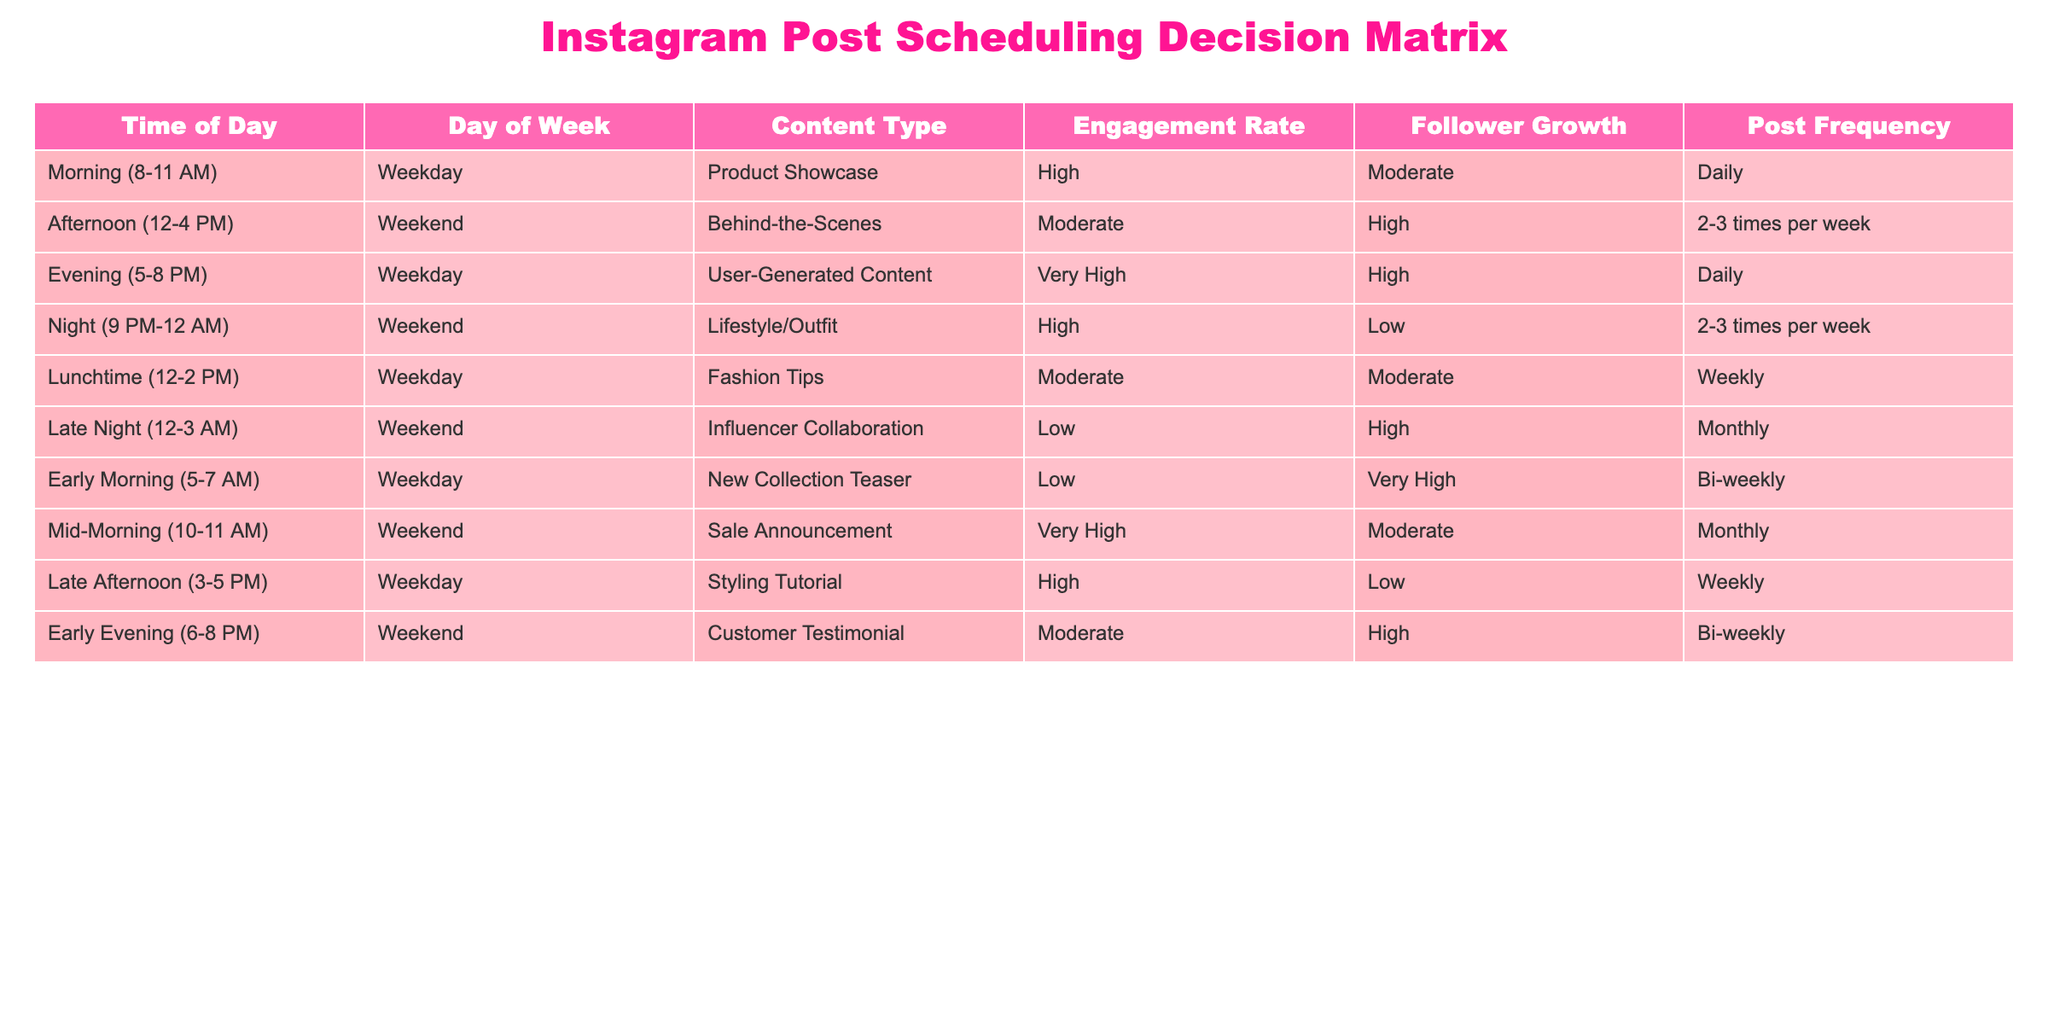What content type is scheduled for posting in the evening on weekdays? According to the table, during the evening time slot (5-8 PM) on weekdays, the content type is "User-Generated Content."
Answer: User-Generated Content What is the post frequency for the "Product Showcase" content type? Looking at the data, the "Product Showcase" content type is scheduled to be posted daily in the morning on weekdays.
Answer: Daily Are there any content types scheduled for both weekdays and weekends? By examining the table, only the "Lifestyle/Outfit" content type is scheduled for weekends, while "Fashion Tips," "Product Showcase," and "User-Generated Content" are only on weekdays. Thus, the answer is no.
Answer: No What is the engagement rate for "Behind-the-Scenes" posts? The engagement rate for "Behind-the-Scenes" content, scheduled for the afternoon on weekends, is labeled as "Moderate."
Answer: Moderate Which time slot has the highest follower growth and what is its content type? Analyzing the follower growth column, the "Behind-the-Scenes" content type during the afternoon on weekends shows a "High" follower growth. This is the highest among the listed time slots and content types.
Answer: Behind-the-Scenes, High Is "New Collection Teaser" content scheduled more frequently than "Sale Announcement"? "New Collection Teaser" is scheduled bi-weekly, while "Sale Announcement" is scheduled monthly. Since bi-weekly is more frequent than monthly, the answer is yes.
Answer: Yes How many content types are scheduled for posting during the "Late Night" time slot on weekends? There is only one content type listed for the "Late Night" time slot (12-3 AM) on weekends, which is "Influencer Collaboration." Therefore, the count is one.
Answer: One What is the average engagement rate for posts during weekdays? The weekday engagement rates from the table are "High," "Moderate," "Very High," and "High." Converting these to numerical values could be High=3, Moderate=2, Very High=4 gives an average of (3+2+4+3)/4 = 3. This suggests a numerical representation where the average engagement rate is generally "High."
Answer: High 